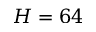Convert formula to latex. <formula><loc_0><loc_0><loc_500><loc_500>H = 6 4</formula> 